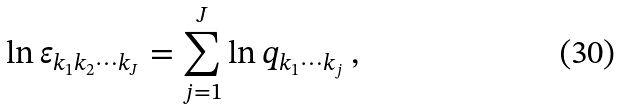Convert formula to latex. <formula><loc_0><loc_0><loc_500><loc_500>\ln \varepsilon _ { k _ { 1 } k _ { 2 } \cdots k _ { J } } = \sum _ { j = 1 } ^ { J } \ln q _ { k _ { 1 } \cdots k _ { j } } \, ,</formula> 